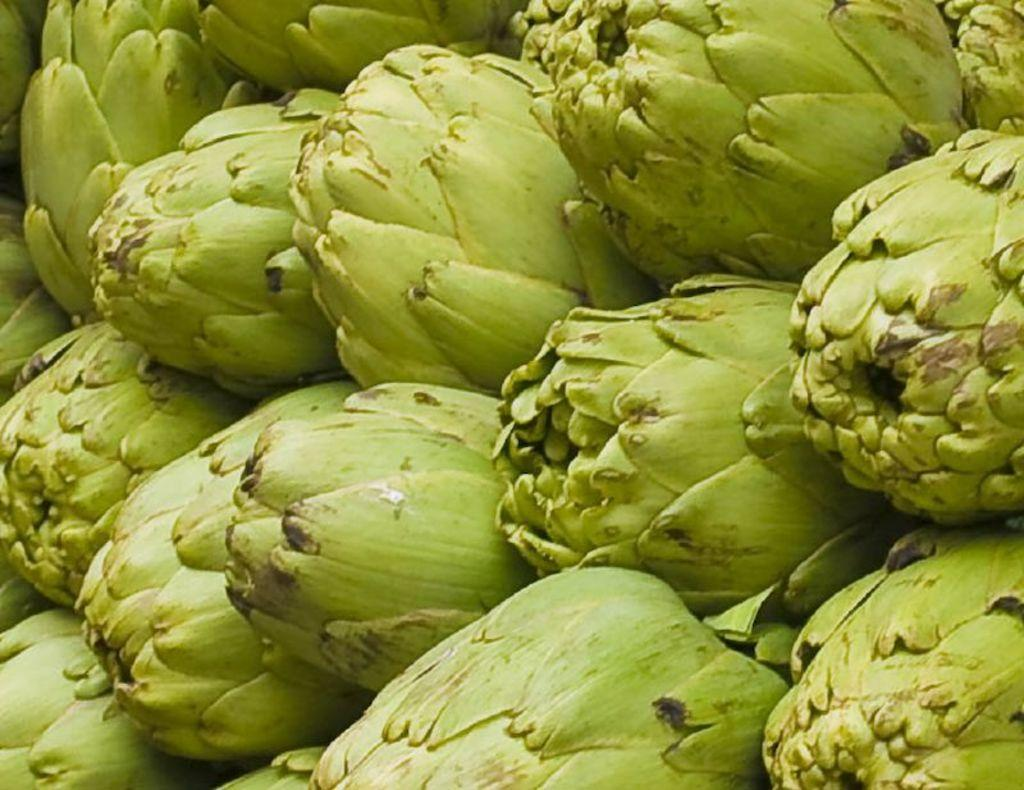What type of food can be seen in the image? There are fruits in the image. What color are the fruits in the image? The fruits are green in color. What type of comb can be seen in the image? There is no comb present in the image; it only features green fruits. 